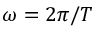Convert formula to latex. <formula><loc_0><loc_0><loc_500><loc_500>\omega = 2 \pi / T</formula> 